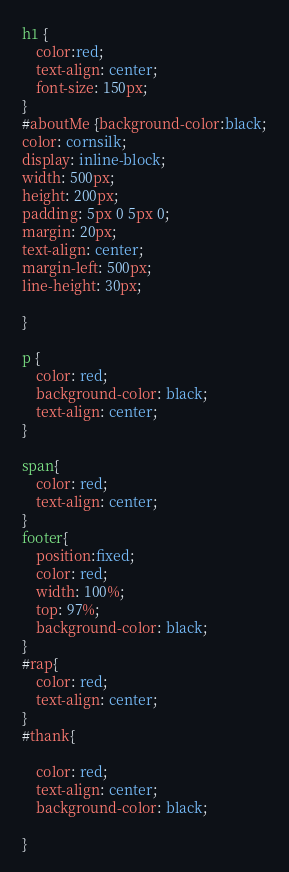<code> <loc_0><loc_0><loc_500><loc_500><_CSS_>h1 {
    color:red;
    text-align: center;
    font-size: 150px;
}
#aboutMe {background-color:black;
color: cornsilk;
display: inline-block;
width: 500px;
height: 200px;
padding: 5px 0 5px 0;
margin: 20px;
text-align: center;
margin-left: 500px;
line-height: 30px;

}

p {
    color: red;
    background-color: black;
    text-align: center;
}

span{
    color: red;
    text-align: center;
}
footer{
    position:fixed;
    color: red;
    width: 100%;
    top: 97%;
    background-color: black;
}
#rap{
    color: red;
    text-align: center;
}
#thank{

    color: red;
    text-align: center;
    background-color: black;

}</code> 